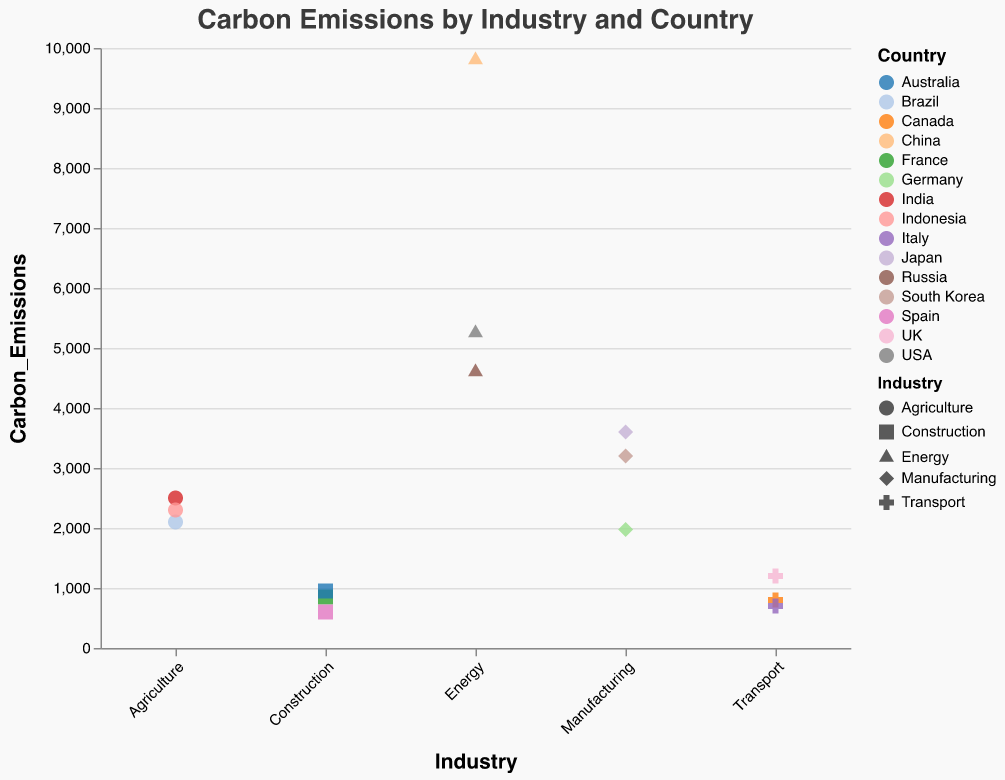Which industry has the highest carbon emissions in the dataset? The highest carbon emissions can be seen in the Energy sector for China, with emissions of 9800.
Answer: Energy (China) Which country has the lowest carbon emissions in the Transport industry? In the Transport industry, Italy has the lowest carbon emissions with a value of 700.
Answer: Italy How many industries have carbon emissions less than 1000 in any country? Inspecting each industry's emissions data by country, we find that Transport (Italy, 700 and Canada, 800) and Construction (France, 850 and Spain, 600) have emissions under 1000, making the total count 2.
Answer: 2 What is the total carbon emissions from the Agriculture industry in India and Brazil combined? The emissions from Agriculture in India are 2500 and in Brazil are 2100. Summing these values gives 2500 + 2100 = 4600.
Answer: 4600 Which country in the Manufacturing industry has higher carbon emissions, Japan or Germany? Comparing the figures in the Manufacturing industry, Japan shows 3600 and Germany 1975. Japan has higher emissions.
Answer: Japan How are the carbon emissions in Agriculture sector of India, Brazil, and Indonesia ranked? In the Agriculture sector, India has 2500, Brazil has 2100, and Indonesia has 2300. Ranking them from highest to lowest: India (2500), Indonesia (2300), Brazil (2100).
Answer: India > Indonesia > Brazil What's the difference in carbon emissions between the Energy sector in the USA and Russia? The USA's carbon emissions in the Energy sector are 5250 and Russia's are 4600. The difference is 5250 - 4600 = 650.
Answer: 650 In which industry does Canada have carbon emissions data? What is the value? Canada has carbon emissions data in the Transport industry, with a value of 800.
Answer: Transport, 800 What's the average carbon emissions across all countries in the Construction industry? The countries in the Construction industry have emissions France (850), Australia (950), and Spain (600). The average is (850 + 950 + 600) / 3 = 800.
Answer: 800 Compare the carbon emissions of the Transport industry in the UK with the Agriculture industry in India. Which one is higher? The carbon emissions for Transport in the UK are 1200, and for Agriculture in India are 2500. Agriculture in India has higher emissions.
Answer: Agriculture in India 